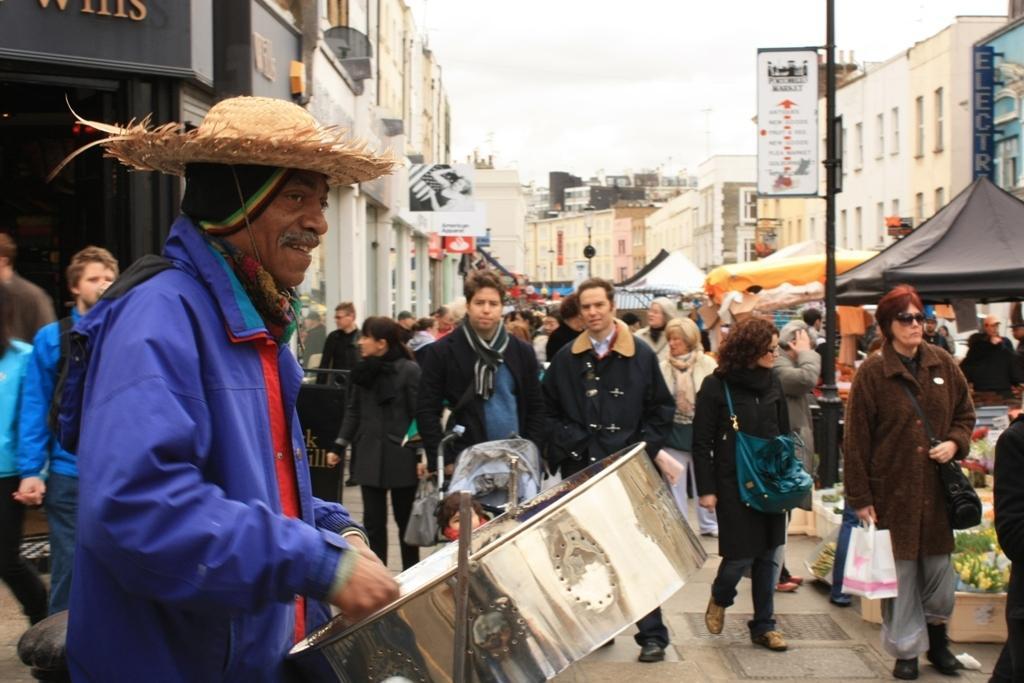How would you summarize this image in a sentence or two? In this picture there is a man who is wearing hat, jacket and playing drum. In the back I can see many people who are walking on the street. On the right I can see the tents and boards. In the background I can see many buildings. At the top I can see the sky and clouds. 